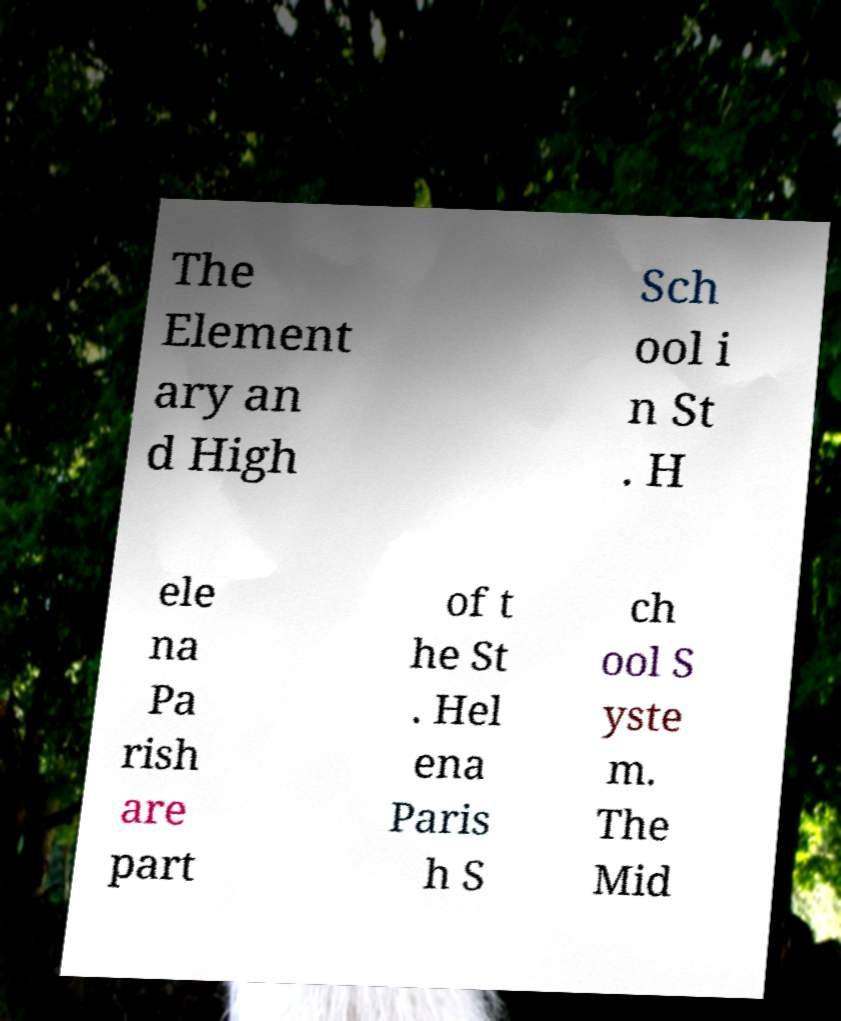Can you accurately transcribe the text from the provided image for me? The Element ary an d High Sch ool i n St . H ele na Pa rish are part of t he St . Hel ena Paris h S ch ool S yste m. The Mid 